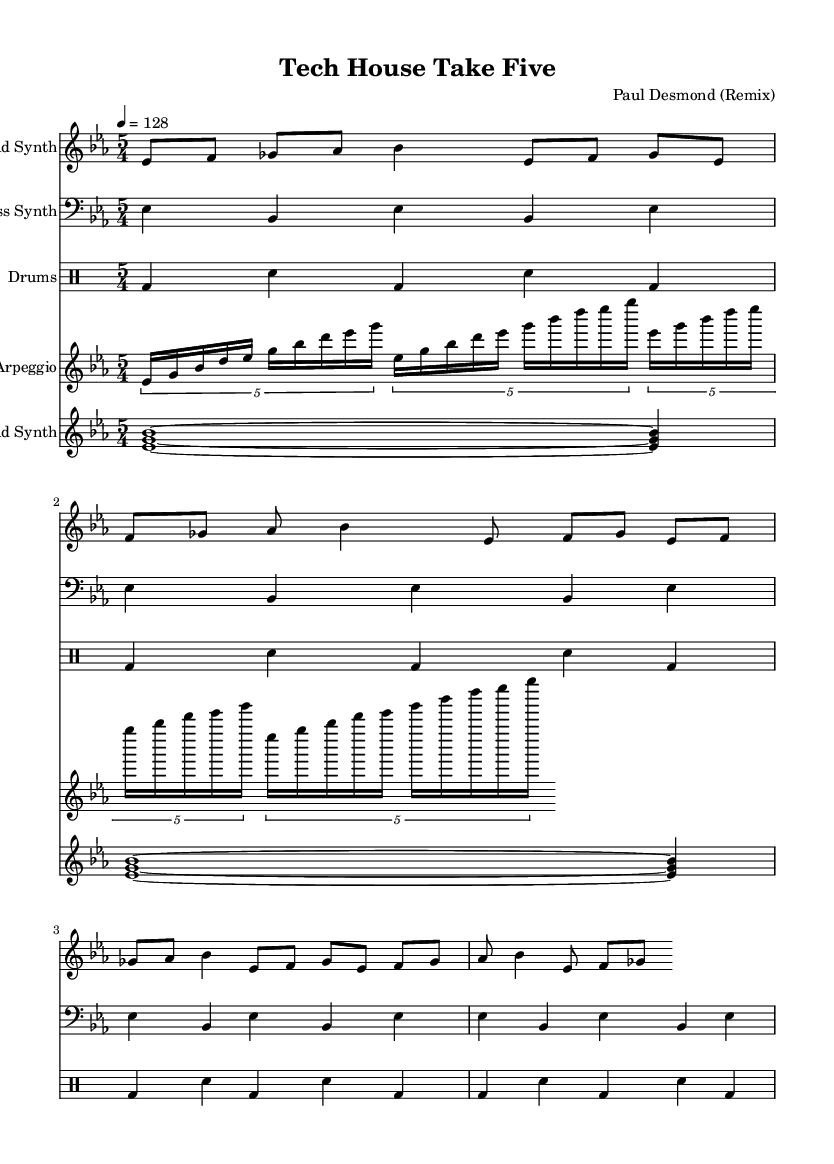What is the key signature of this music? The key signature of the music is found in the opening of the sheet music, showing two flats. This indicates that the piece is in the key of E flat major.
Answer: E flat major What is the time signature of this music? The time signature is located near the beginning of the music sheet, indicated as 5/4. This means there are five beats in each measure, and the quarter note gets one beat.
Answer: 5/4 What is the tempo marking for this piece? The tempo is specified in the second line of the header section. It indicates that the piece should be played at 128 beats per minute.
Answer: 128 How many measures does the lead synth section have? By counting the number of repetitions in the lead synth part, we see there are four distinct measures that repeat throughout this section of the sheet music.
Answer: Four What is the primary musical texture of the piece? Analyzing the arrangement in the score, one can observe multiple layers including lead synth, bass synth, drums, and arpeggio, indicating a complex texture typical of tech house music.
Answer: Layered What rhythmic element is prominent in the drum pattern? The drum pattern uses a consistent kick drum (bd) followed by snare (sn), creating a regular groove that's characteristic of house music. This emphasizes the strong beats typical in dance music.
Answer: Kick and snare Which jazz standard is being remixed in this piece? The title refers to "Take Five," which is a well-known jazz composition by Paul Desmond, recognized for its unique time signature and melodic character.
Answer: Take Five 